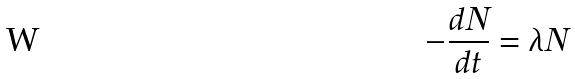<formula> <loc_0><loc_0><loc_500><loc_500>- \frac { d N } { d t } = \lambda N</formula> 